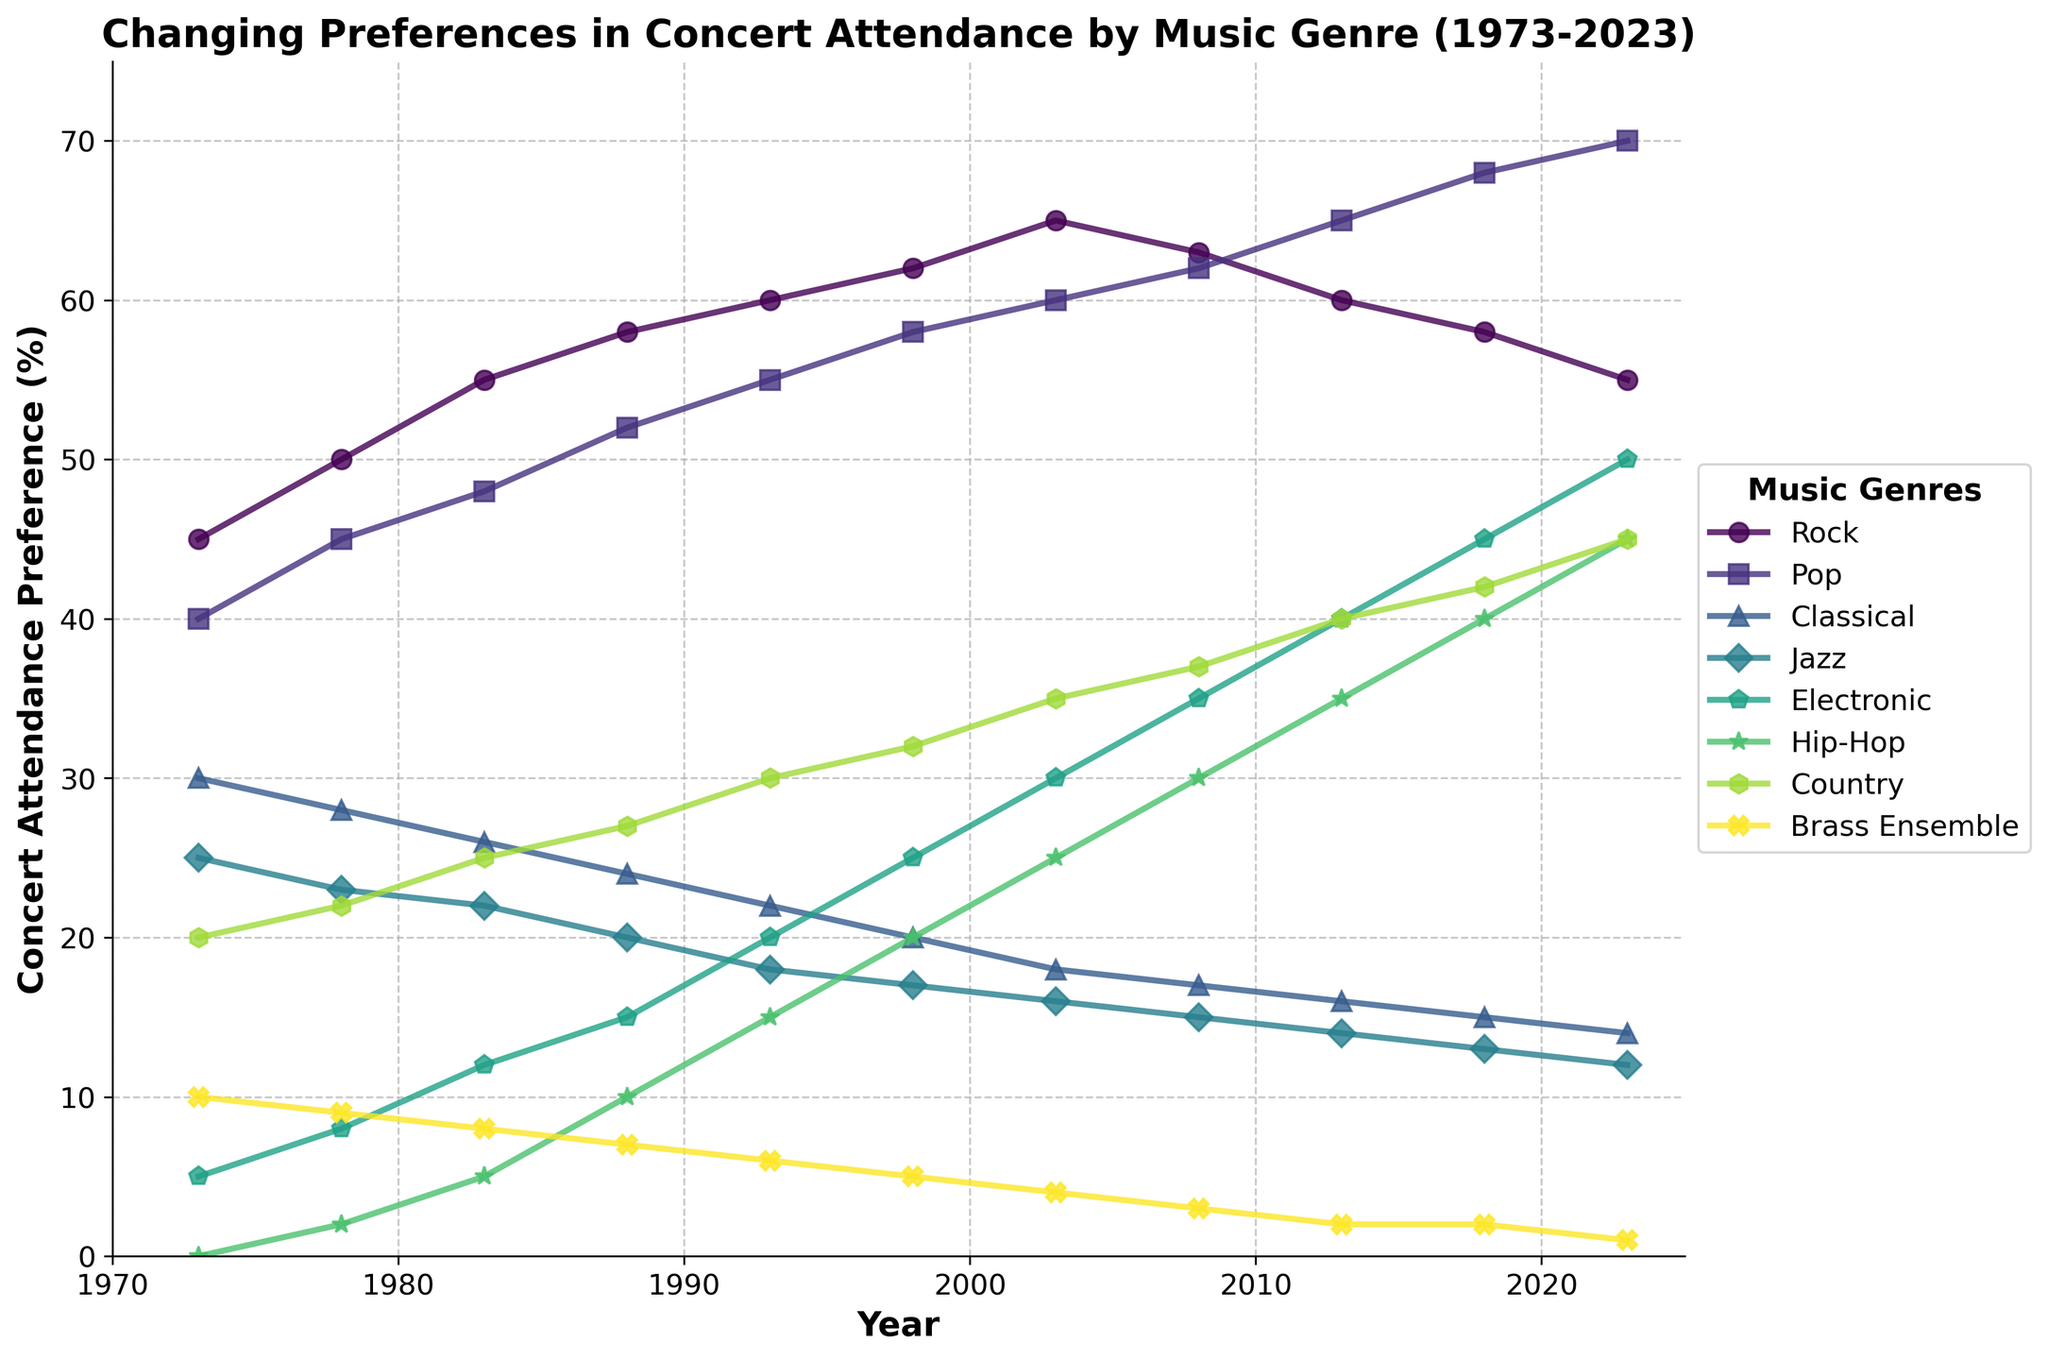What is the overall trend for Rock concert attendance from 1973 to 2023? Over the 50-year period, the line depicting Rock concert attendance generally trends upward, starting at 45% in 1973 and reaching its peak around 2003 at 65%, after which it slightly declines to 55% by 2023.
Answer: Increasing Which genre experienced the highest increase in concert attendance preference over the 50 years? By looking at the chart, it’s clear that Electronic music experienced the highest increase. It started at 5% in 1973 and reached 50% in 2023, an increase of 45 percentage points.
Answer: Electronic In which year did Pop concert attendance surpass Rock concert attendance? In the chart, Pop concert attendance surpasses Rock concert attendance in the year 2013.
Answer: 2013 Which genre is least preferred in 2023, and what is its percentage? The least preferred genre in 2023 is Brass Ensemble, with a concert attendance preference of 1%.
Answer: Brass Ensemble, 1% Compare the concert attendance preferences of Jazz and Classical music in 1983. Which one was higher and by how much? In 1983, Jazz concert attendance was at 22% and Classical was at 26%. Classical concert attendance was higher by 4%.
Answer: Classical, 4% Identify the years when Jazz concert attendance was higher than Electronic concert attendance. Jazz concert attendance was higher than Electronic concert attendance from 1973 to 1983.
Answer: 1973, 1978, 1983 What is the visual representation (color, marker) of the Country genre in the chart? The Country genre is represented with a color from the viridis color palette and uses a 'h' marker.
Answer: Viridis color, 'h' marker Between which two years did Hip-Hop experience the largest increase in concert attendance preference? The largest increase in Hip-Hop concert attendance preference occurred between 2008 and 2013, where it increased from 30% to 35%.
Answer: 2008-2013 If you add the preferences of Pop and Hip-Hop in 2023, what is the total percentage? In 2023, the preference for Pop is 70% and for Hip-Hop is 45%. Adding them together, the total is 115%.
Answer: 115% What is the percentage difference between Country concert attendance in 1973 and 2023? In 1973, Country concert attendance was 20%, and in 2023 it is 45%. The difference is 25 percentage points.
Answer: 25% 